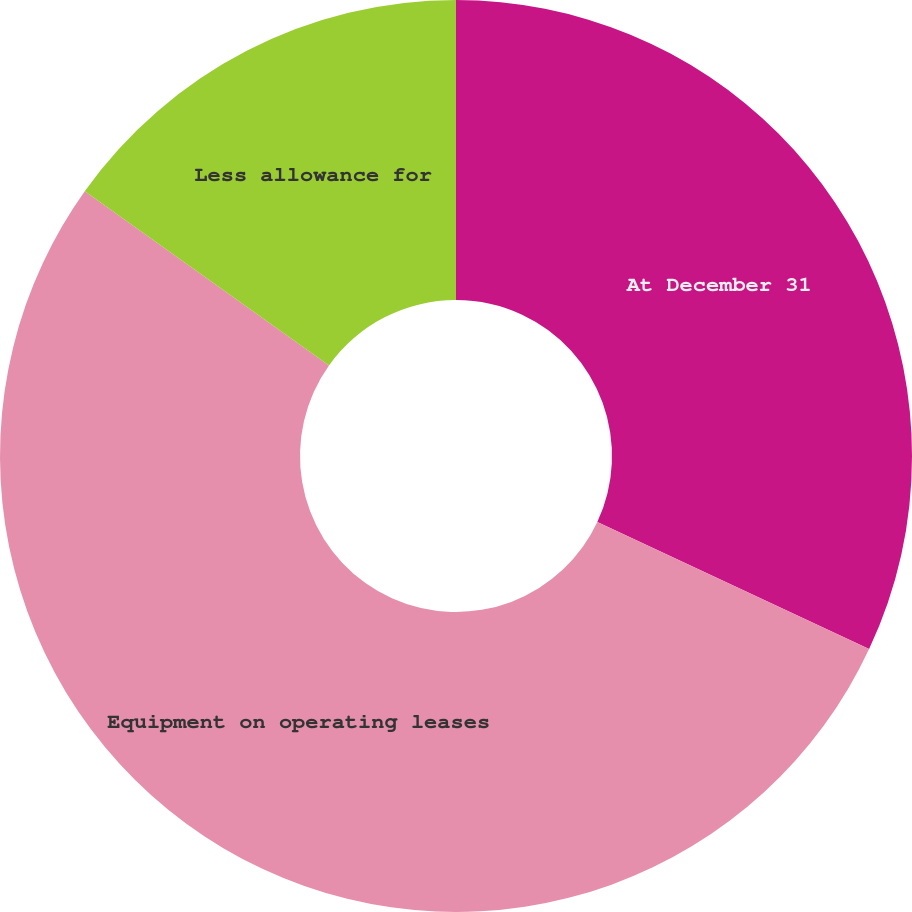<chart> <loc_0><loc_0><loc_500><loc_500><pie_chart><fcel>At December 31<fcel>Equipment on operating leases<fcel>Less allowance for<nl><fcel>31.96%<fcel>52.9%<fcel>15.14%<nl></chart> 